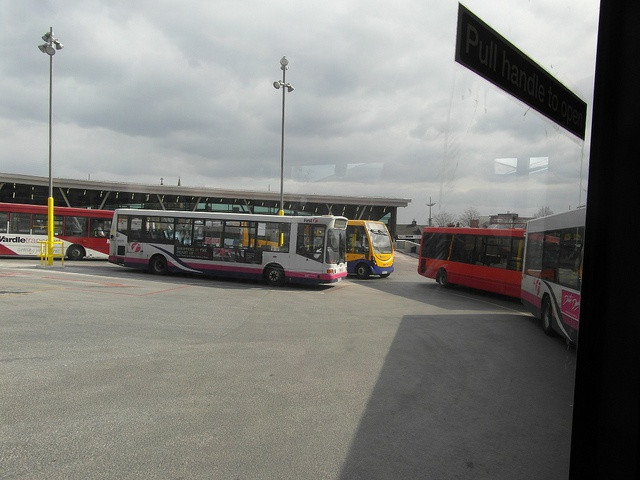Describe the objects in this image and their specific colors. I can see bus in lightgray, black, gray, and maroon tones, bus in lightgray, black, gray, and maroon tones, bus in lightgray, black, maroon, gray, and brown tones, bus in lightgray, black, maroon, gray, and darkgray tones, and bus in lightgray, black, darkgray, gray, and olive tones in this image. 